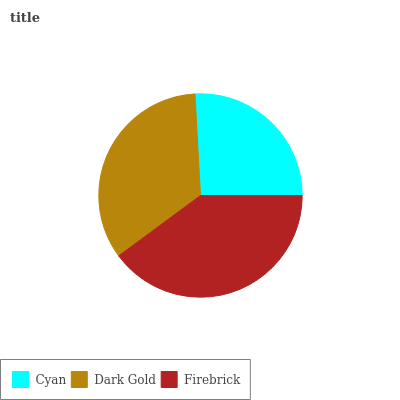Is Cyan the minimum?
Answer yes or no. Yes. Is Firebrick the maximum?
Answer yes or no. Yes. Is Dark Gold the minimum?
Answer yes or no. No. Is Dark Gold the maximum?
Answer yes or no. No. Is Dark Gold greater than Cyan?
Answer yes or no. Yes. Is Cyan less than Dark Gold?
Answer yes or no. Yes. Is Cyan greater than Dark Gold?
Answer yes or no. No. Is Dark Gold less than Cyan?
Answer yes or no. No. Is Dark Gold the high median?
Answer yes or no. Yes. Is Dark Gold the low median?
Answer yes or no. Yes. Is Firebrick the high median?
Answer yes or no. No. Is Firebrick the low median?
Answer yes or no. No. 